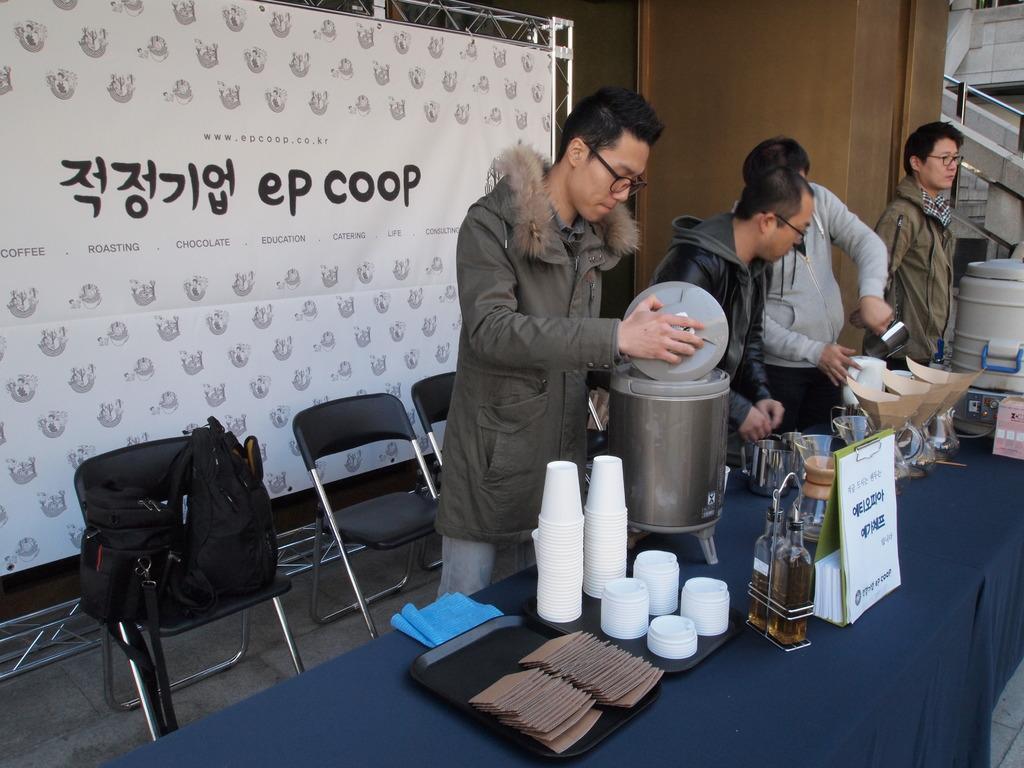Can you describe this image briefly? In this image I can see few people and holding something. In front I can see a glasses,bottles,board,jars and some objects on the blue color table. Back I can see a black color chairs and bag is on the chair. I can see a white color banner and something is written on it. 